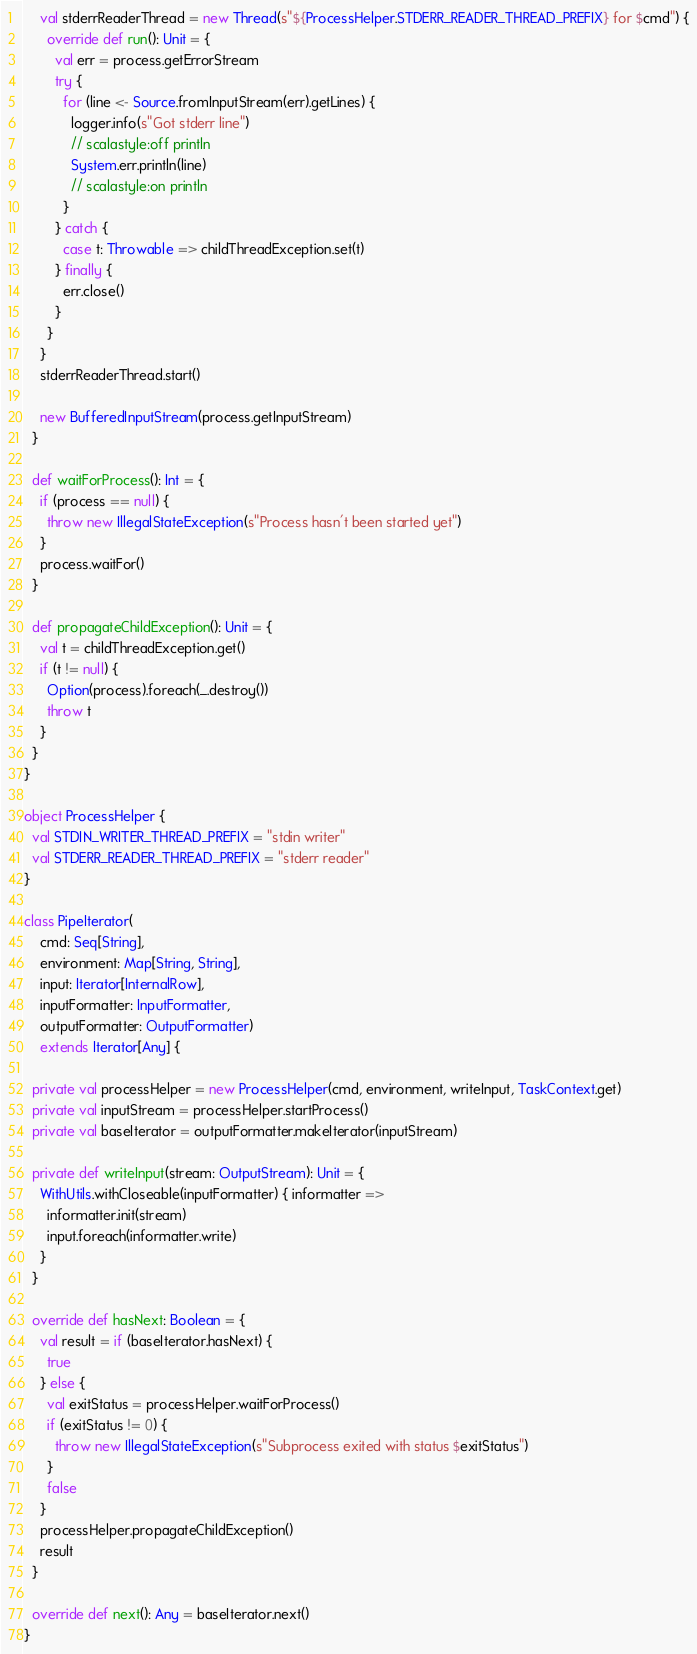<code> <loc_0><loc_0><loc_500><loc_500><_Scala_>    val stderrReaderThread = new Thread(s"${ProcessHelper.STDERR_READER_THREAD_PREFIX} for $cmd") {
      override def run(): Unit = {
        val err = process.getErrorStream
        try {
          for (line <- Source.fromInputStream(err).getLines) {
            logger.info(s"Got stderr line")
            // scalastyle:off println
            System.err.println(line)
            // scalastyle:on println
          }
        } catch {
          case t: Throwable => childThreadException.set(t)
        } finally {
          err.close()
        }
      }
    }
    stderrReaderThread.start()

    new BufferedInputStream(process.getInputStream)
  }

  def waitForProcess(): Int = {
    if (process == null) {
      throw new IllegalStateException(s"Process hasn't been started yet")
    }
    process.waitFor()
  }

  def propagateChildException(): Unit = {
    val t = childThreadException.get()
    if (t != null) {
      Option(process).foreach(_.destroy())
      throw t
    }
  }
}

object ProcessHelper {
  val STDIN_WRITER_THREAD_PREFIX = "stdin writer"
  val STDERR_READER_THREAD_PREFIX = "stderr reader"
}

class PipeIterator(
    cmd: Seq[String],
    environment: Map[String, String],
    input: Iterator[InternalRow],
    inputFormatter: InputFormatter,
    outputFormatter: OutputFormatter)
    extends Iterator[Any] {

  private val processHelper = new ProcessHelper(cmd, environment, writeInput, TaskContext.get)
  private val inputStream = processHelper.startProcess()
  private val baseIterator = outputFormatter.makeIterator(inputStream)

  private def writeInput(stream: OutputStream): Unit = {
    WithUtils.withCloseable(inputFormatter) { informatter =>
      informatter.init(stream)
      input.foreach(informatter.write)
    }
  }

  override def hasNext: Boolean = {
    val result = if (baseIterator.hasNext) {
      true
    } else {
      val exitStatus = processHelper.waitForProcess()
      if (exitStatus != 0) {
        throw new IllegalStateException(s"Subprocess exited with status $exitStatus")
      }
      false
    }
    processHelper.propagateChildException()
    result
  }

  override def next(): Any = baseIterator.next()
}
</code> 